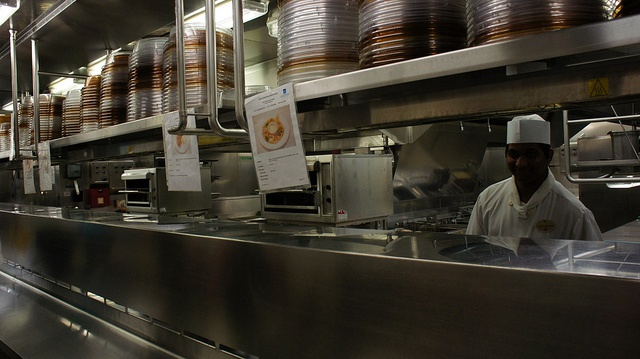Describe the objects in this image and their specific colors. I can see people in black and gray tones, oven in black and gray tones, and microwave in black and gray tones in this image. 